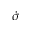<formula> <loc_0><loc_0><loc_500><loc_500>\ D o t { \sigma }</formula> 